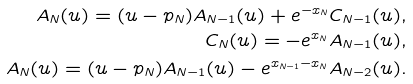<formula> <loc_0><loc_0><loc_500><loc_500>A _ { N } ( u ) = ( u - p _ { N } ) A _ { N - 1 } ( u ) + e ^ { - x _ { N } } C _ { N - 1 } ( u ) , \\ C _ { N } ( u ) = - e ^ { x _ { N } } A _ { N - 1 } ( u ) , \\ A _ { N } ( u ) = ( u - p _ { N } ) A _ { N - 1 } ( u ) - e ^ { x _ { N - 1 } - x _ { N } } A _ { N - 2 } ( u ) .</formula> 